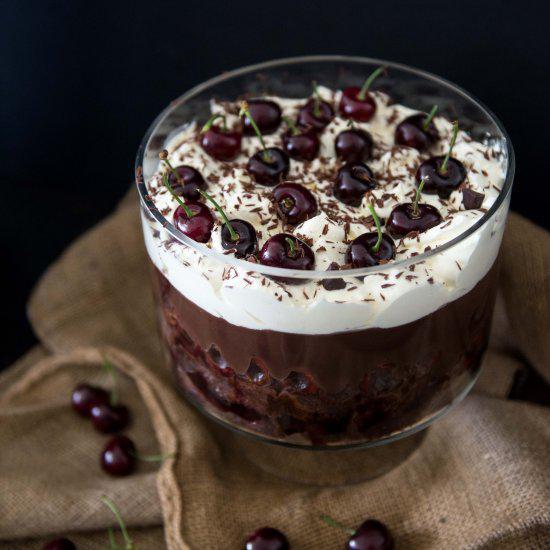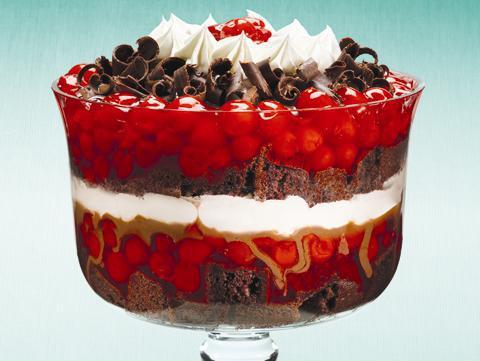The first image is the image on the left, the second image is the image on the right. Analyze the images presented: Is the assertion "there are two trifles in the image pair" valid? Answer yes or no. Yes. The first image is the image on the left, the second image is the image on the right. Evaluate the accuracy of this statement regarding the images: "In the right image, there are at least three chocolate deserts.". Is it true? Answer yes or no. No. 